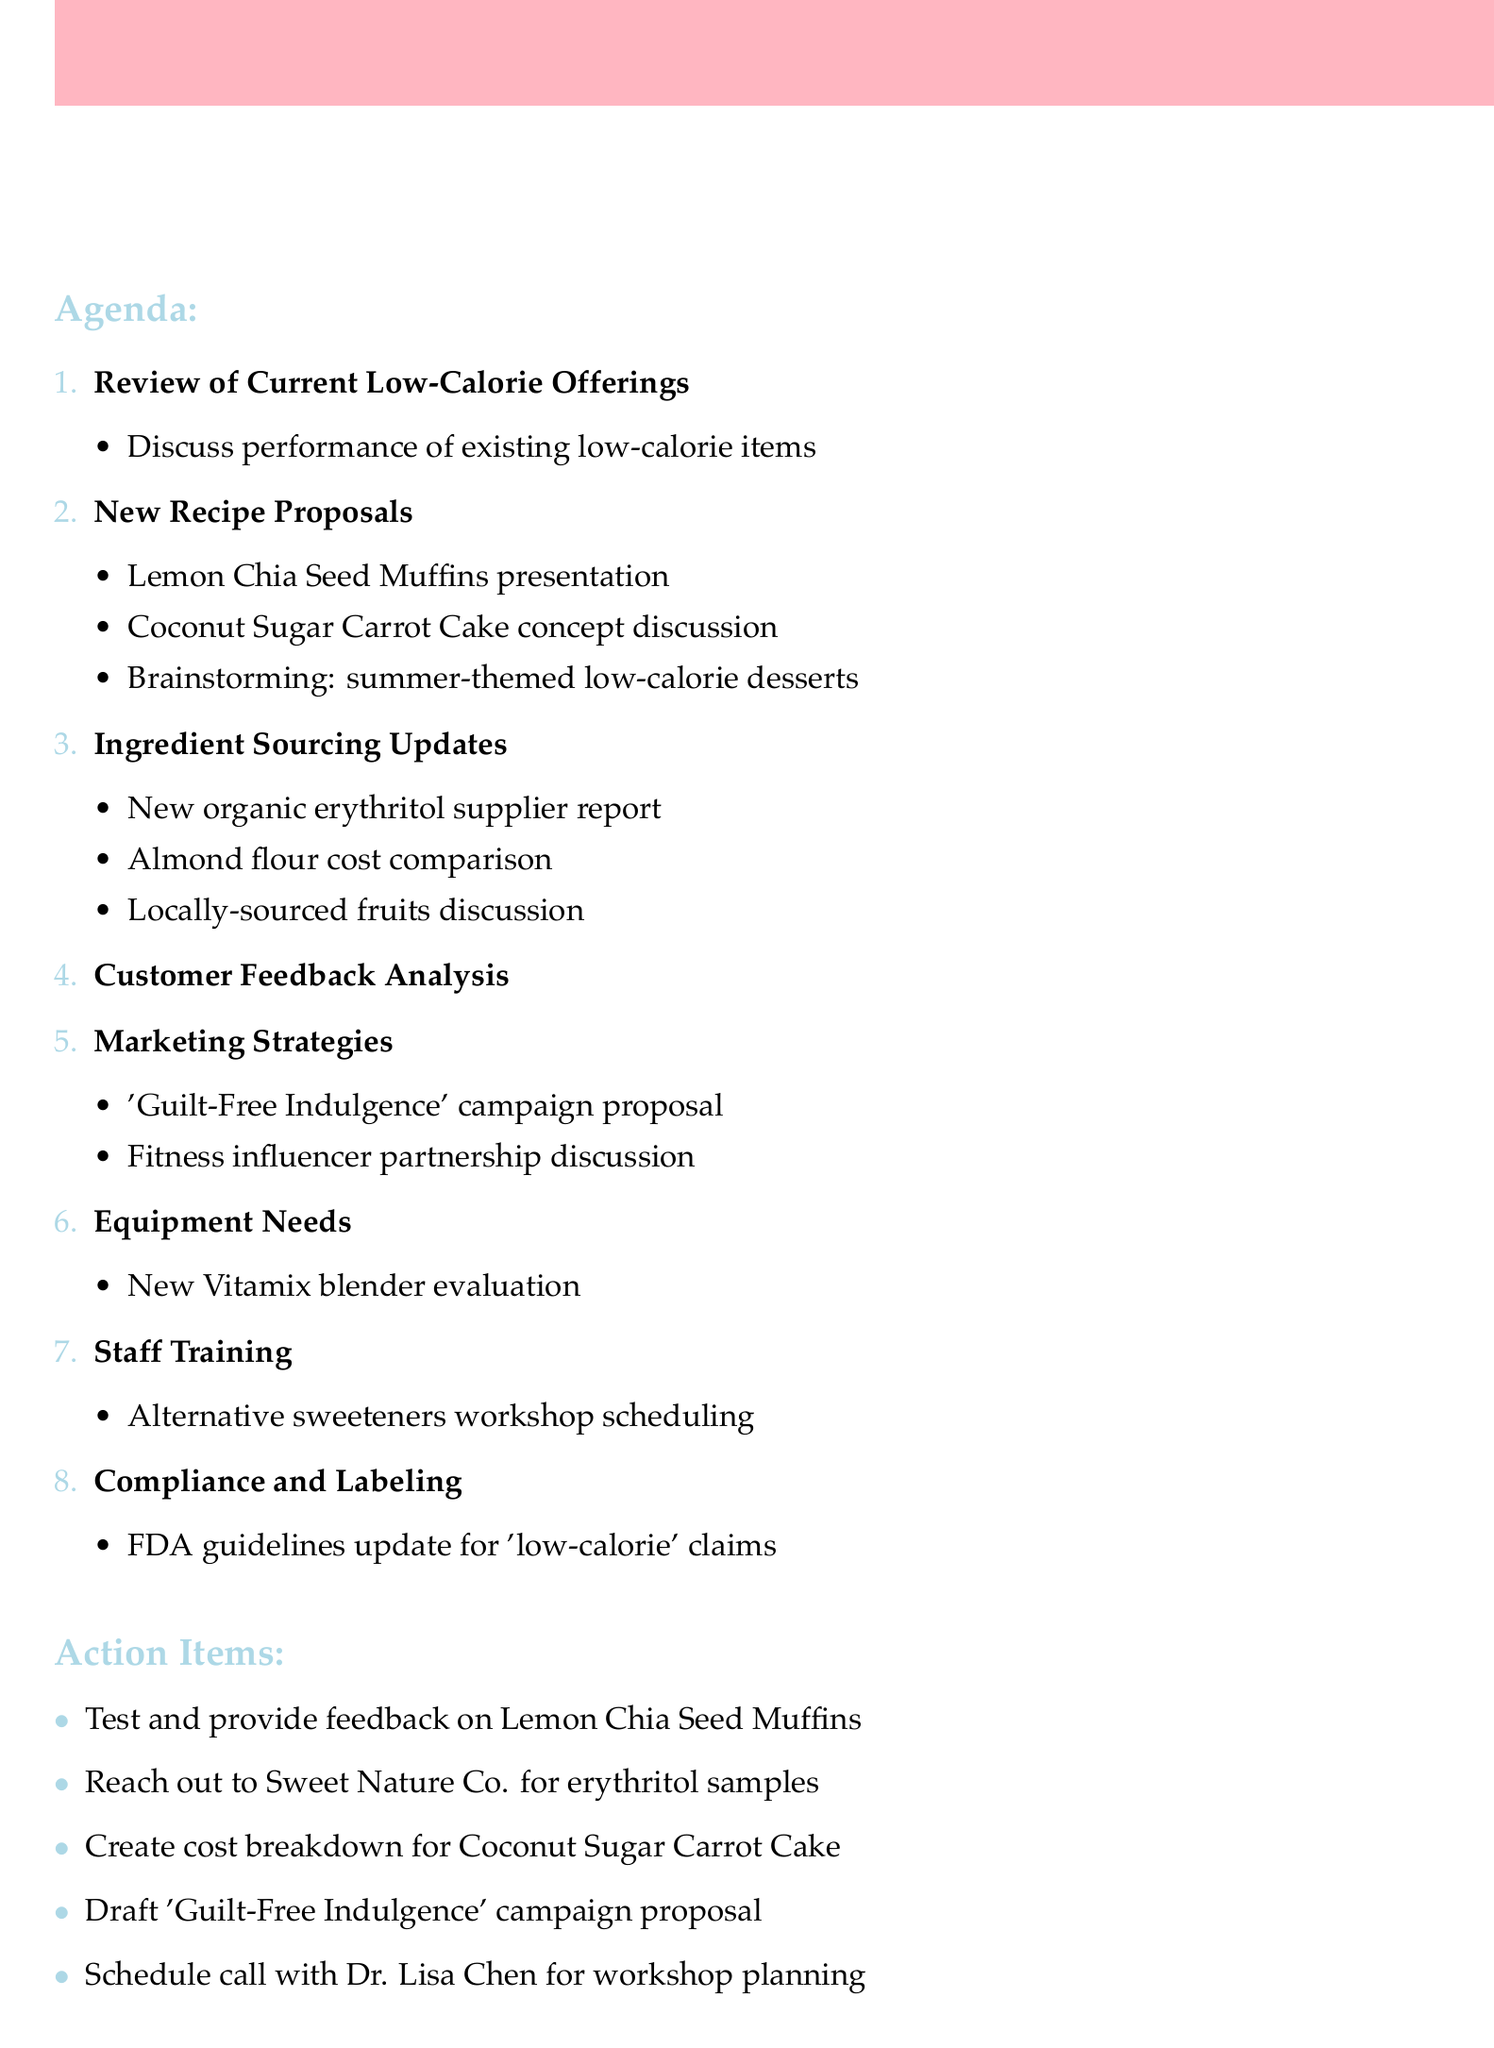What is the date of the meeting? The date of the meeting is listed in the overview section of the document.
Answer: May 15, 2023 Who will present the Lemon Chia Seed Muffins? The presentation details are listed under the new recipe proposals section, indicating who is responsible for each presentation.
Answer: Head Baker Sarah What is being discussed in the Ingredient Sourcing Updates? The details in this agenda item outline several topics related to ingredient sourcing.
Answer: New organic erythritol supplier How long is the meeting scheduled to last? The duration can be calculated from the start and end times provided in the overview section.
Answer: 2 hours What is the purpose of the 'Guilt-Free Indulgence' campaign? The campaign's purpose is mentioned in the marketing strategies item of the agenda.
Answer: Product promotion What do staff need to provide feedback on? This action item indicates what staff are responsible for testing and reviewing after the meeting.
Answer: Lemon Chia Seed Muffins How many agenda items are there? The number of agenda items can be counted from the list provided in the document.
Answer: 8 Who is leading the workshop on alternative sweeteners? The staff training agenda item specifies who is responsible for leading the workshop.
Answer: Dr. Lisa Chen 